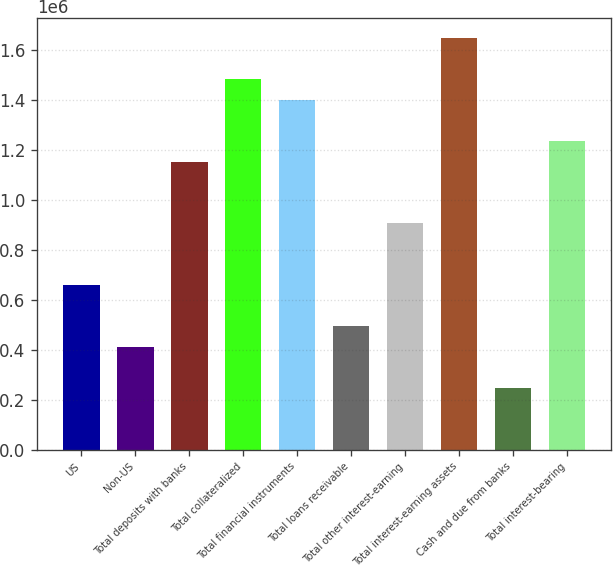Convert chart. <chart><loc_0><loc_0><loc_500><loc_500><bar_chart><fcel>US<fcel>Non-US<fcel>Total deposits with banks<fcel>Total collateralized<fcel>Total financial instruments<fcel>Total loans receivable<fcel>Total other interest-earning<fcel>Total interest-earning assets<fcel>Cash and due from banks<fcel>Total interest-bearing<nl><fcel>658921<fcel>411835<fcel>1.15309e+06<fcel>1.48254e+06<fcel>1.40018e+06<fcel>494197<fcel>906007<fcel>1.64726e+06<fcel>247111<fcel>1.23545e+06<nl></chart> 